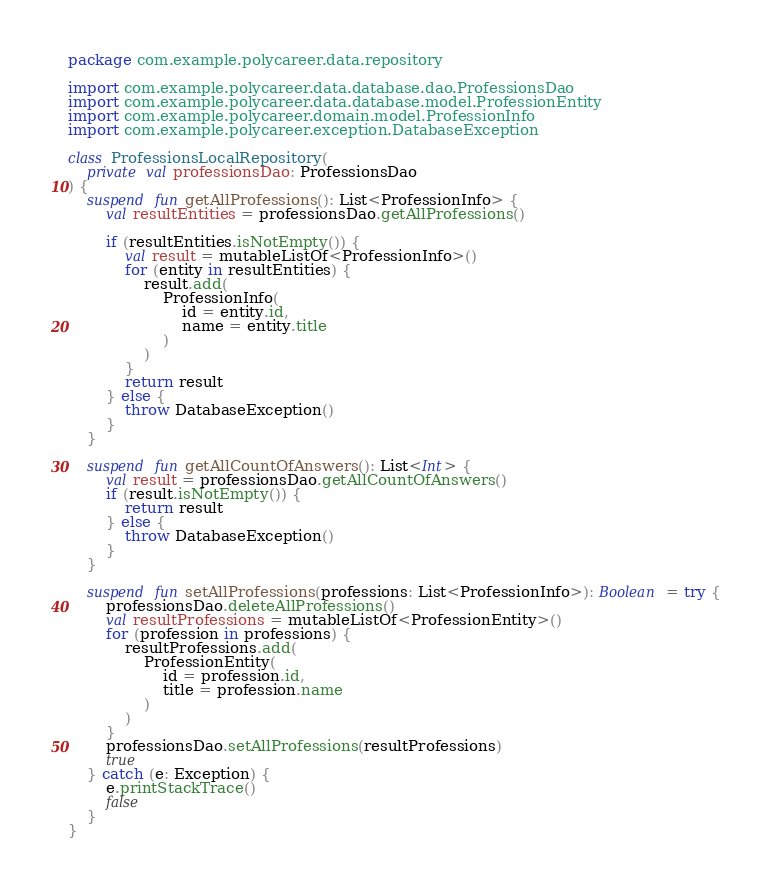Convert code to text. <code><loc_0><loc_0><loc_500><loc_500><_Kotlin_>package com.example.polycareer.data.repository

import com.example.polycareer.data.database.dao.ProfessionsDao
import com.example.polycareer.data.database.model.ProfessionEntity
import com.example.polycareer.domain.model.ProfessionInfo
import com.example.polycareer.exception.DatabaseException

class ProfessionsLocalRepository(
    private val professionsDao: ProfessionsDao
) {
    suspend fun getAllProfessions(): List<ProfessionInfo> {
        val resultEntities = professionsDao.getAllProfessions()

        if (resultEntities.isNotEmpty()) {
            val result = mutableListOf<ProfessionInfo>()
            for (entity in resultEntities) {
                result.add(
                    ProfessionInfo(
                        id = entity.id,
                        name = entity.title
                    )
                )
            }
            return result
        } else {
            throw DatabaseException()
        }
    }

    suspend fun getAllCountOfAnswers(): List<Int> {
        val result = professionsDao.getAllCountOfAnswers()
        if (result.isNotEmpty()) {
            return result
        } else {
            throw DatabaseException()
        }
    }

    suspend fun setAllProfessions(professions: List<ProfessionInfo>): Boolean = try {
        professionsDao.deleteAllProfessions()
        val resultProfessions = mutableListOf<ProfessionEntity>()
        for (profession in professions) {
            resultProfessions.add(
                ProfessionEntity(
                    id = profession.id,
                    title = profession.name
                )
            )
        }
        professionsDao.setAllProfessions(resultProfessions)
        true
    } catch (e: Exception) {
        e.printStackTrace()
        false
    }
}
</code> 